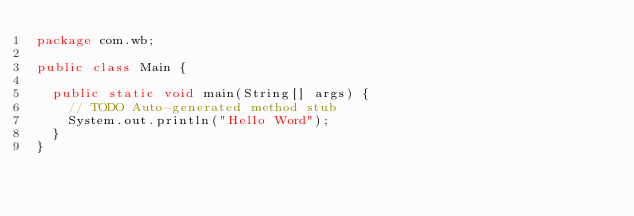<code> <loc_0><loc_0><loc_500><loc_500><_Java_>package com.wb;

public class Main {

	public static void main(String[] args) {
		// TODO Auto-generated method stub
		System.out.println("Hello Word");
	}
}
</code> 